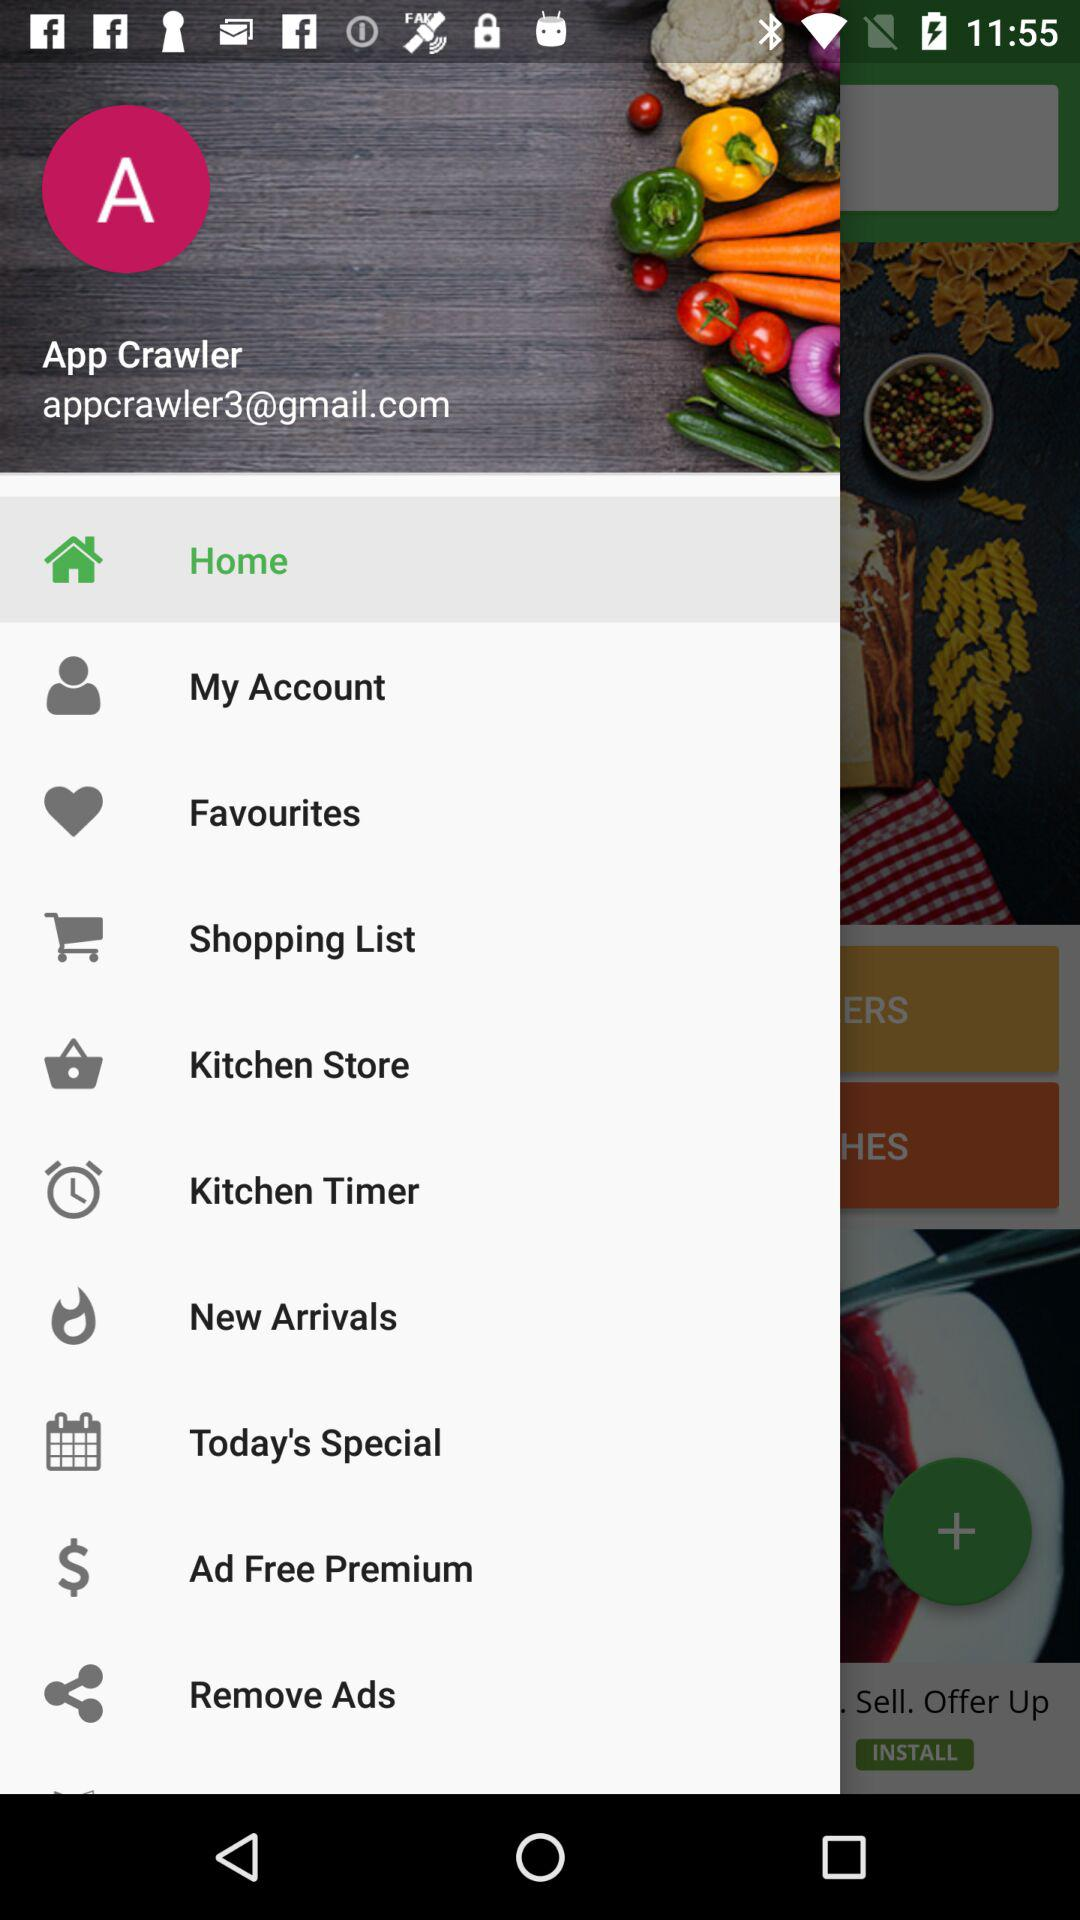What is the given email address? The given email address is appcrawler3@gmail.com. 